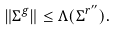Convert formula to latex. <formula><loc_0><loc_0><loc_500><loc_500>\| \Sigma ^ { g } \| \leq \Lambda ( \Sigma ^ { r ^ { \prime \prime } } ) .</formula> 